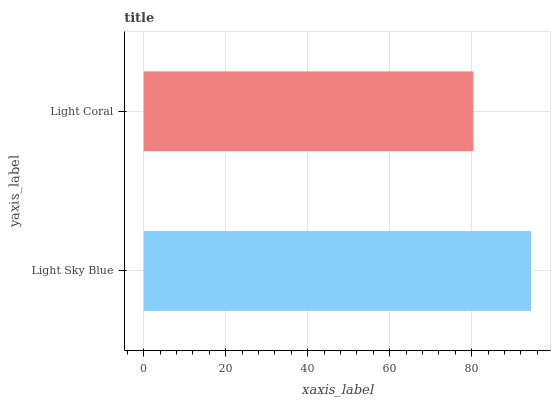Is Light Coral the minimum?
Answer yes or no. Yes. Is Light Sky Blue the maximum?
Answer yes or no. Yes. Is Light Coral the maximum?
Answer yes or no. No. Is Light Sky Blue greater than Light Coral?
Answer yes or no. Yes. Is Light Coral less than Light Sky Blue?
Answer yes or no. Yes. Is Light Coral greater than Light Sky Blue?
Answer yes or no. No. Is Light Sky Blue less than Light Coral?
Answer yes or no. No. Is Light Sky Blue the high median?
Answer yes or no. Yes. Is Light Coral the low median?
Answer yes or no. Yes. Is Light Coral the high median?
Answer yes or no. No. Is Light Sky Blue the low median?
Answer yes or no. No. 